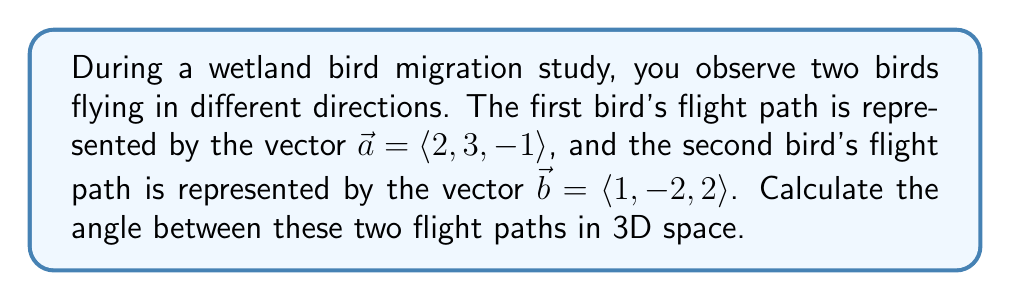Help me with this question. To find the angle between two vectors in 3D space, we can use the dot product formula:

$$\cos \theta = \frac{\vec{a} \cdot \vec{b}}{|\vec{a}| |\vec{b}|}$$

Where $\theta$ is the angle between the vectors, $\vec{a} \cdot \vec{b}$ is the dot product, and $|\vec{a}|$ and $|\vec{b}|$ are the magnitudes of the vectors.

Step 1: Calculate the dot product $\vec{a} \cdot \vec{b}$
$$\vec{a} \cdot \vec{b} = (2)(1) + (3)(-2) + (-1)(2) = 2 - 6 - 2 = -6$$

Step 2: Calculate the magnitudes of $\vec{a}$ and $\vec{b}$
$$|\vec{a}| = \sqrt{2^2 + 3^2 + (-1)^2} = \sqrt{4 + 9 + 1} = \sqrt{14}$$
$$|\vec{b}| = \sqrt{1^2 + (-2)^2 + 2^2} = \sqrt{1 + 4 + 4} = 3$$

Step 3: Substitute the values into the dot product formula
$$\cos \theta = \frac{-6}{\sqrt{14} \cdot 3} = \frac{-6}{3\sqrt{14}}$$

Step 4: Take the inverse cosine (arccos) of both sides
$$\theta = \arccos\left(\frac{-6}{3\sqrt{14}}\right)$$

Step 5: Calculate the final angle in degrees
$$\theta \approx 2.4307 \text{ radians} \approx 139.3°$$
Answer: $139.3°$ 